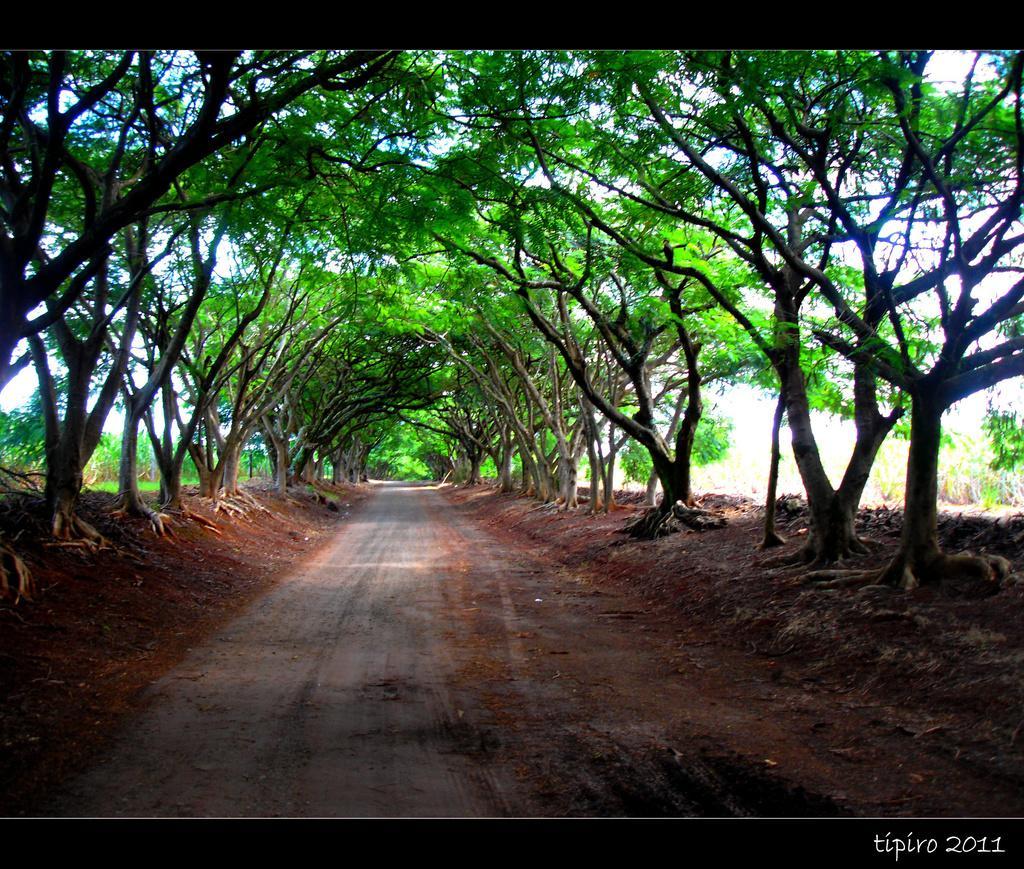Can you describe this image briefly? There is a walkway and around the walkway there are many trees and in the background there is a sky. 